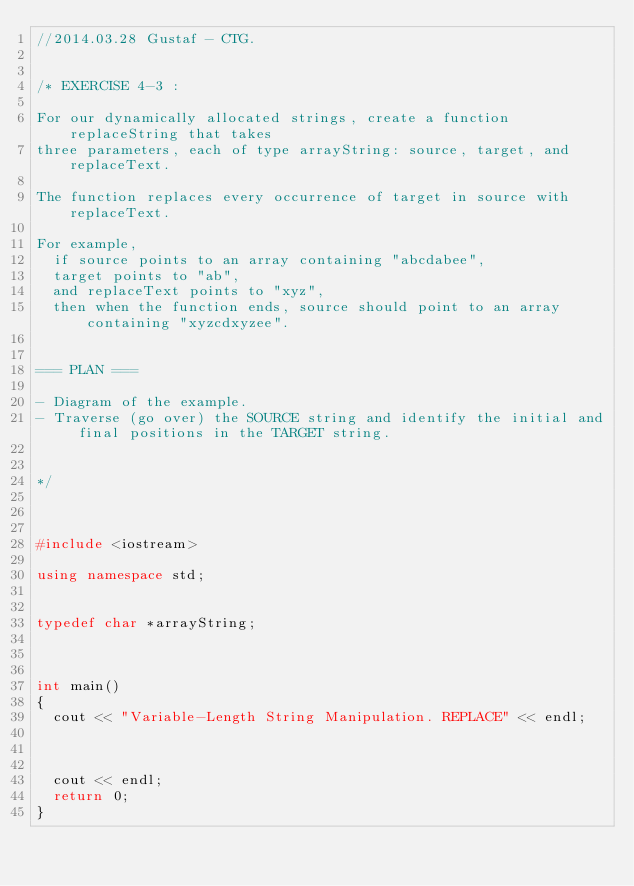Convert code to text. <code><loc_0><loc_0><loc_500><loc_500><_C++_>//2014.03.28 Gustaf - CTG.


/* EXERCISE 4-3 :

For our dynamically allocated strings, create a function replaceString that takes
three parameters, each of type arrayString: source, target, and replaceText.

The function replaces every occurrence of target in source with replaceText.

For example,
  if source points to an array containing "abcdabee",
  target points to "ab",
  and replaceText points to "xyz",
  then when the function ends, source should point to an array containing "xyzcdxyzee".


=== PLAN ===

- Diagram of the example.
- Traverse (go over) the SOURCE string and identify the initial and final positions in the TARGET string.


*/



#include <iostream>

using namespace std;


typedef char *arrayString;



int main()
{
  cout << "Variable-Length String Manipulation. REPLACE" << endl;



  cout << endl;
  return 0;
}
</code> 